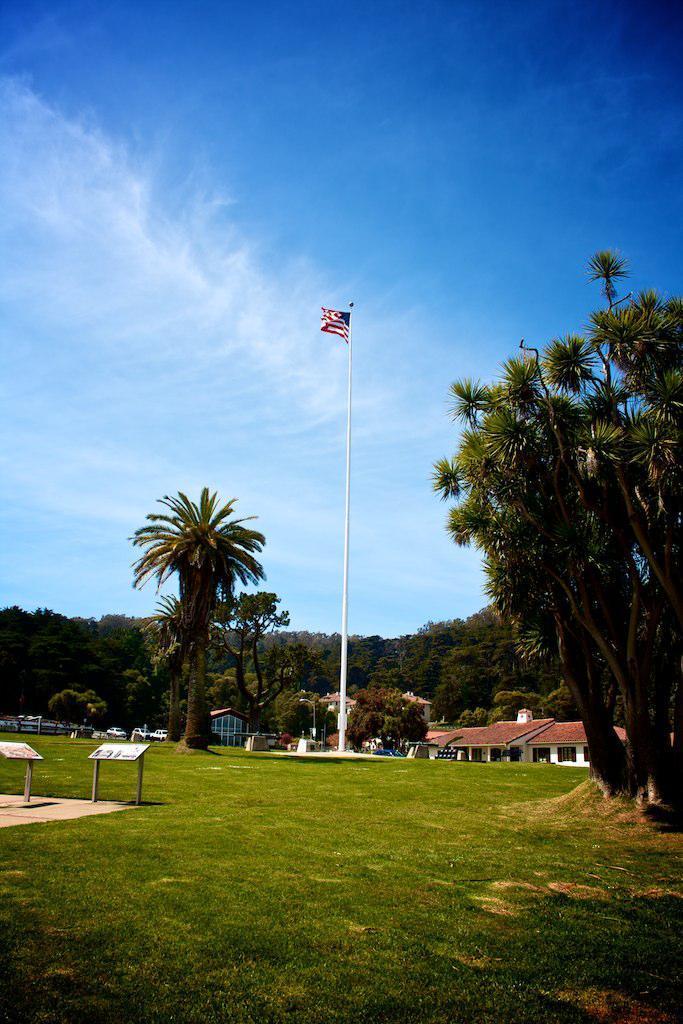Can you describe this image briefly? At the top we can see a clear blue sky. In the background we can see trees and houses. This is a flag. Here we can see grass. On the right side of the picture we can see a tree. 